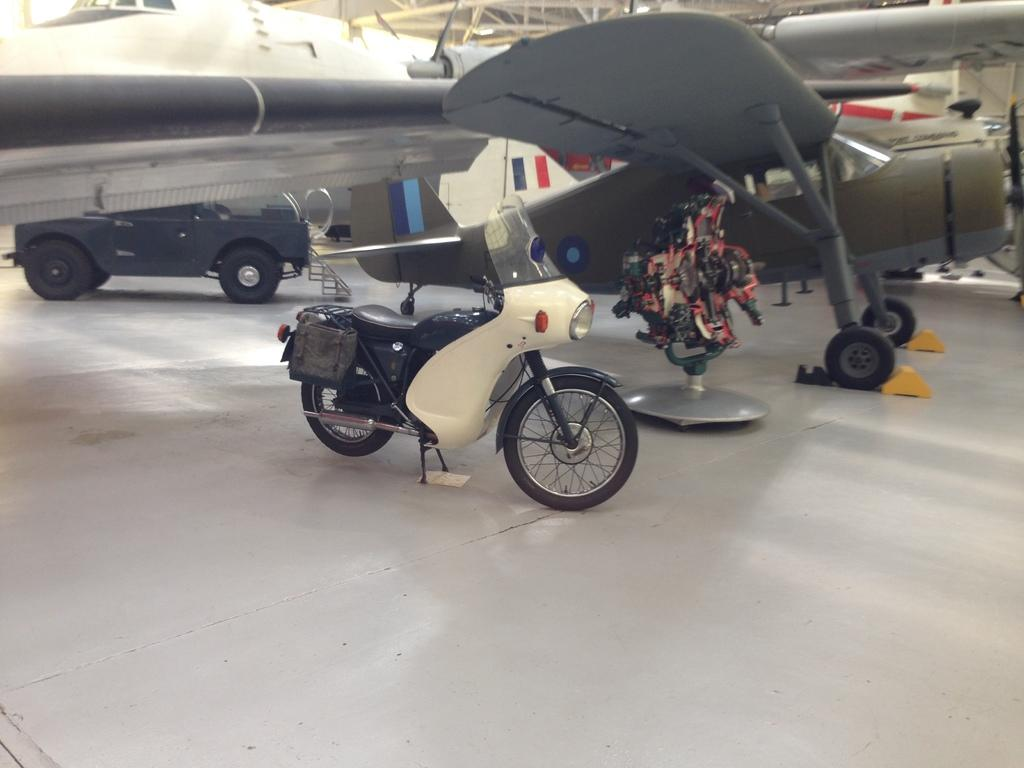What type of vehicle is in the image? There is a motorcycle in the image. What other type of vehicle is in the image? There is an aircraft in the image. What can be seen on the aircraft? The aircraft has logos printed on it. What colors are visible in the image? There are red and black colors visible in the image. What type of patch can be seen on the lettuce in the image? There is no lettuce or patch present in the image. 